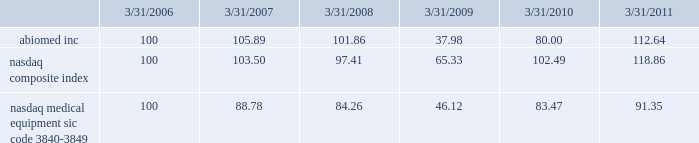Performance graph the following graph compares the yearly change in the cumulative total stockholder return for our last five full fiscal years , based upon the market price of our common stock , with the cumulative total return on a nasdaq composite index ( u.s .
Companies ) and a peer group , the nasdaq medical equipment-sic code 3840-3849 index , which is comprised of medical equipment companies , for that period .
The performance graph assumes the investment of $ 100 on march 31 , 2006 in our common stock , the nasdaq composite index ( u.s .
Companies ) and the peer group index , and the reinvestment of any and all dividends. .
This graph is not 201csoliciting material 201d under regulation 14a or 14c of the rules promulgated under the securities exchange act of 1934 , is not deemed filed with the securities and exchange commission and is not to be incorporated by reference in any of our filings under the securities act of 1933 , as amended , or the exchange act whether made before or after the date hereof and irrespective of any general incorporation language in any such filing .
Transfer agent american stock transfer & trust company , 59 maiden lane , new york , ny 10038 , is our stock transfer agent. .
Did abiomed inc outperform the nasdaq composite index? 
Computations: (112.64 > 118.86)
Answer: no. Performance graph the following graph compares the yearly change in the cumulative total stockholder return for our last five full fiscal years , based upon the market price of our common stock , with the cumulative total return on a nasdaq composite index ( u.s .
Companies ) and a peer group , the nasdaq medical equipment-sic code 3840-3849 index , which is comprised of medical equipment companies , for that period .
The performance graph assumes the investment of $ 100 on march 31 , 2006 in our common stock , the nasdaq composite index ( u.s .
Companies ) and the peer group index , and the reinvestment of any and all dividends. .
This graph is not 201csoliciting material 201d under regulation 14a or 14c of the rules promulgated under the securities exchange act of 1934 , is not deemed filed with the securities and exchange commission and is not to be incorporated by reference in any of our filings under the securities act of 1933 , as amended , or the exchange act whether made before or after the date hereof and irrespective of any general incorporation language in any such filing .
Transfer agent american stock transfer & trust company , 59 maiden lane , new york , ny 10038 , is our stock transfer agent. .
Did abiomed inc , outperform the nasdaq medical equipment index?\\n? 
Computations: (112.64 > 91.35)
Answer: yes. Performance graph the following graph compares the yearly change in the cumulative total stockholder return for our last five full fiscal years , based upon the market price of our common stock , with the cumulative total return on a nasdaq composite index ( u.s .
Companies ) and a peer group , the nasdaq medical equipment-sic code 3840-3849 index , which is comprised of medical equipment companies , for that period .
The performance graph assumes the investment of $ 100 on march 31 , 2006 in our common stock , the nasdaq composite index ( u.s .
Companies ) and the peer group index , and the reinvestment of any and all dividends. .
This graph is not 201csoliciting material 201d under regulation 14a or 14c of the rules promulgated under the securities exchange act of 1934 , is not deemed filed with the securities and exchange commission and is not to be incorporated by reference in any of our filings under the securities act of 1933 , as amended , or the exchange act whether made before or after the date hereof and irrespective of any general incorporation language in any such filing .
Transfer agent american stock transfer & trust company , 59 maiden lane , new york , ny 10038 , is our stock transfer agent. .
What is the roi of an investment in nasdaq composite index from march 2006 to march 2009? 
Computations: ((65.33 - 100) / 100)
Answer: -0.3467. Performance graph the following graph compares the yearly change in the cumulative total stockholder return for our last five full fiscal years , based upon the market price of our common stock , with the cumulative total return on a nasdaq composite index ( u.s .
Companies ) and a peer group , the nasdaq medical equipment-sic code 3840-3849 index , which is comprised of medical equipment companies , for that period .
The performance graph assumes the investment of $ 100 on march 31 , 2006 in our common stock , the nasdaq composite index ( u.s .
Companies ) and the peer group index , and the reinvestment of any and all dividends. .
This graph is not 201csoliciting material 201d under regulation 14a or 14c of the rules promulgated under the securities exchange act of 1934 , is not deemed filed with the securities and exchange commission and is not to be incorporated by reference in any of our filings under the securities act of 1933 , as amended , or the exchange act whether made before or after the date hereof and irrespective of any general incorporation language in any such filing .
Transfer agent american stock transfer & trust company , 59 maiden lane , new york , ny 10038 , is our stock transfer agent. .
What is the roi of an investment in abiomed inc from march 2006 to march 2009? 
Computations: ((37.98 - 100) / 100)
Answer: -0.6202. 